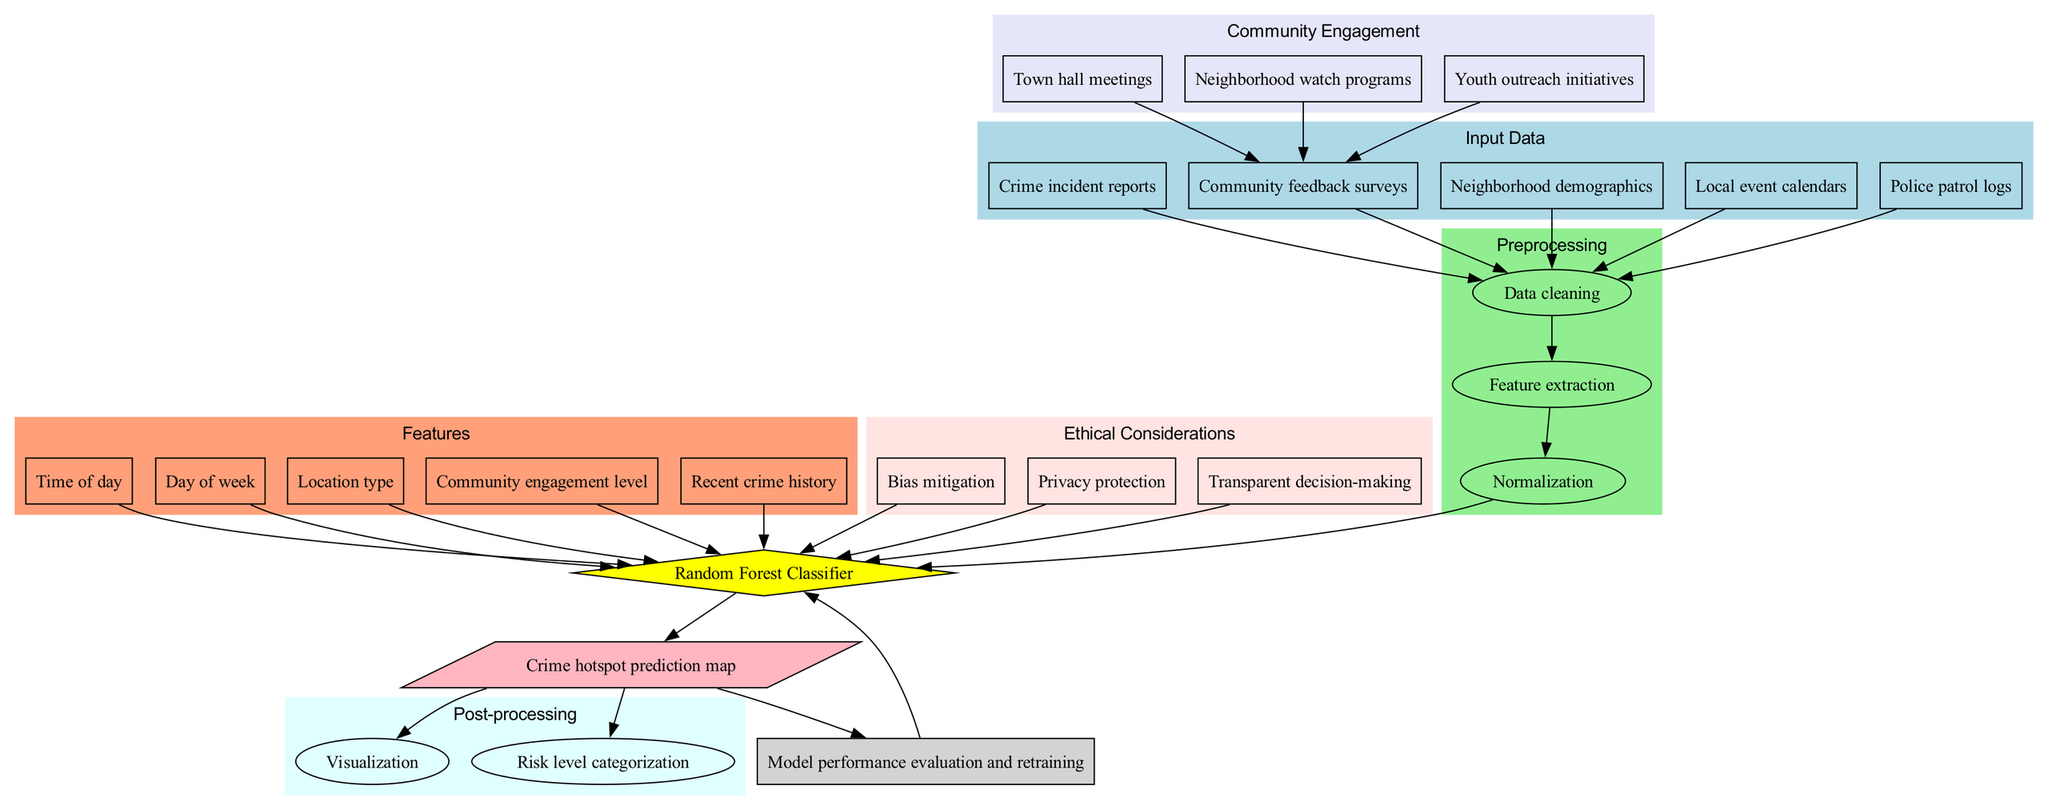What are the input data types for the model? The diagram shows five input data types: Crime incident reports, Community feedback surveys, Neighborhood demographics, Local event calendars, and Police patrol logs. These inputs are visually grouped in the "Input Data" section.
Answer: Crime incident reports, Community feedback surveys, Neighborhood demographics, Local event calendars, Police patrol logs How many preprocessing steps are there in the model? The "Preprocessing" section contains three steps: Data cleaning, Feature extraction, and Normalization. Counting these steps gives a total of three preprocessing steps.
Answer: 3 What is the model used in this diagram? The model node is clearly labeled as "Random Forest Classifier," which is visibly positioned in the center of the diagram under the model section.
Answer: Random Forest Classifier What are the community engagement activities connected to the model? The diagram lists three community engagement activities: Town hall meetings, Neighborhood watch programs, and Youth outreach initiatives. These are grouped under the "Community Engagement" section, illustrating their connection to community feedback surveys.
Answer: Town hall meetings, Neighborhood watch programs, Youth outreach initiatives What is the output of the machine learning model? The output node labeled is "Crime hotspot prediction map," which visually connects to the model and indicates the final product generated by the model.
Answer: Crime hotspot prediction map How does the feedback loop work in the model? The diagram indicates that the output connects to the feedback loop before it links back to the model. This suggests that the model's performance evaluation and retraining occur based on the output results, creating a cycle of improvement.
Answer: Model performance evaluation and retraining Which ethical consideration is linked to the model? The diagram shows multiple ethical considerations, including Bias mitigation, Privacy protection, and Transparent decision-making, which all directly connect to the model. The question asks for a specific link, and any consideration would suffice as a valid answer based on the diagram.
Answer: Bias mitigation, Privacy protection, Transparent decision-making What type of visualization is included in the post-processing stage? The diagram reveals that the post-processing stage includes "Visualization" and "Risk level categorization." Here, "Visualization" is the element that directly correlates with the diagram's focus on presenting the model's output.
Answer: Visualization What is the first preprocessing step in the diagram? The connections in the diagram show that "Data cleaning" is the first step after the input data, as there is an arrow leading from all input data types to this node.
Answer: Data cleaning 